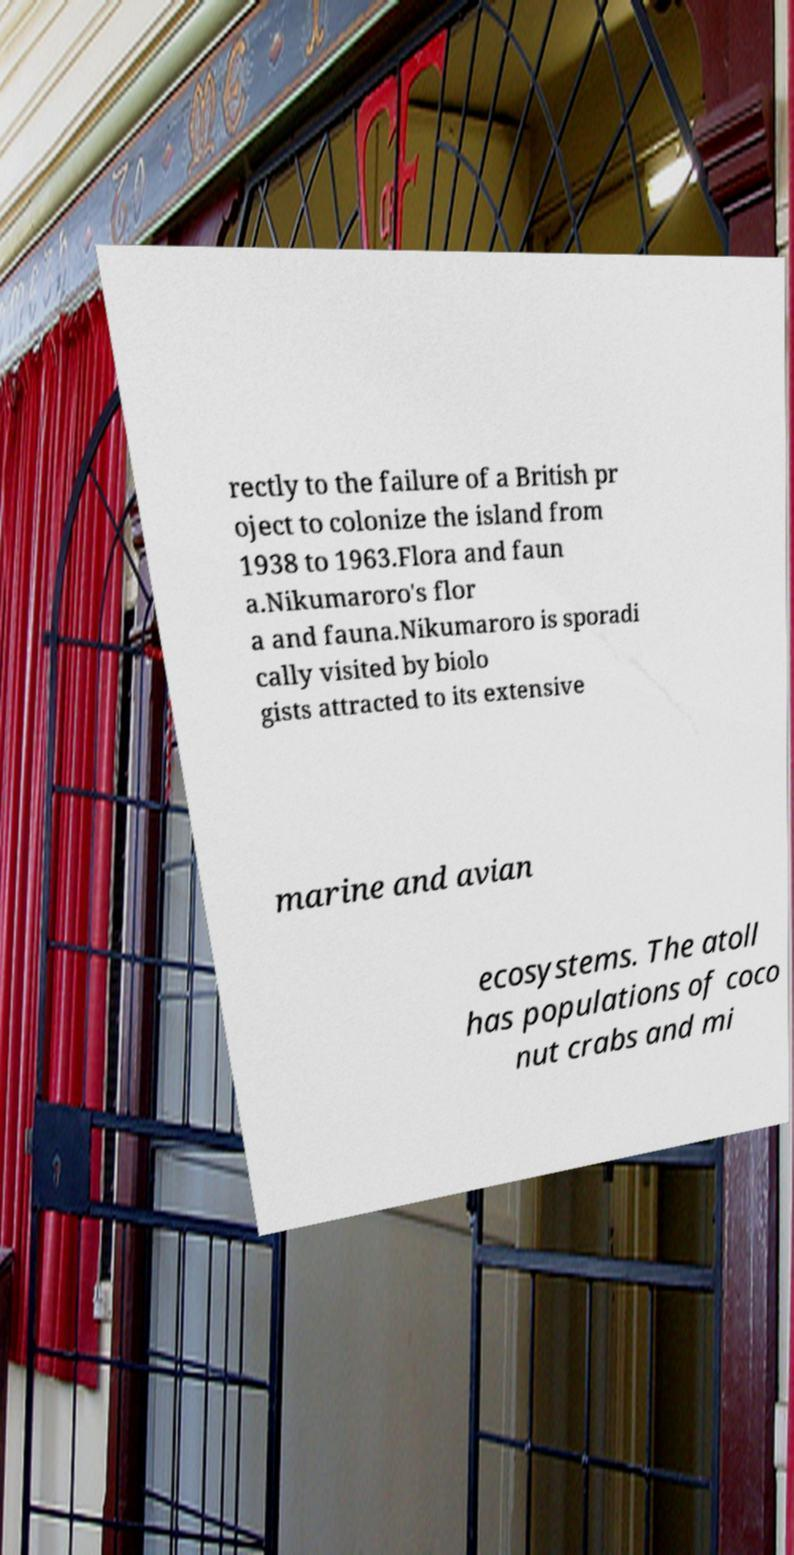There's text embedded in this image that I need extracted. Can you transcribe it verbatim? rectly to the failure of a British pr oject to colonize the island from 1938 to 1963.Flora and faun a.Nikumaroro's flor a and fauna.Nikumaroro is sporadi cally visited by biolo gists attracted to its extensive marine and avian ecosystems. The atoll has populations of coco nut crabs and mi 